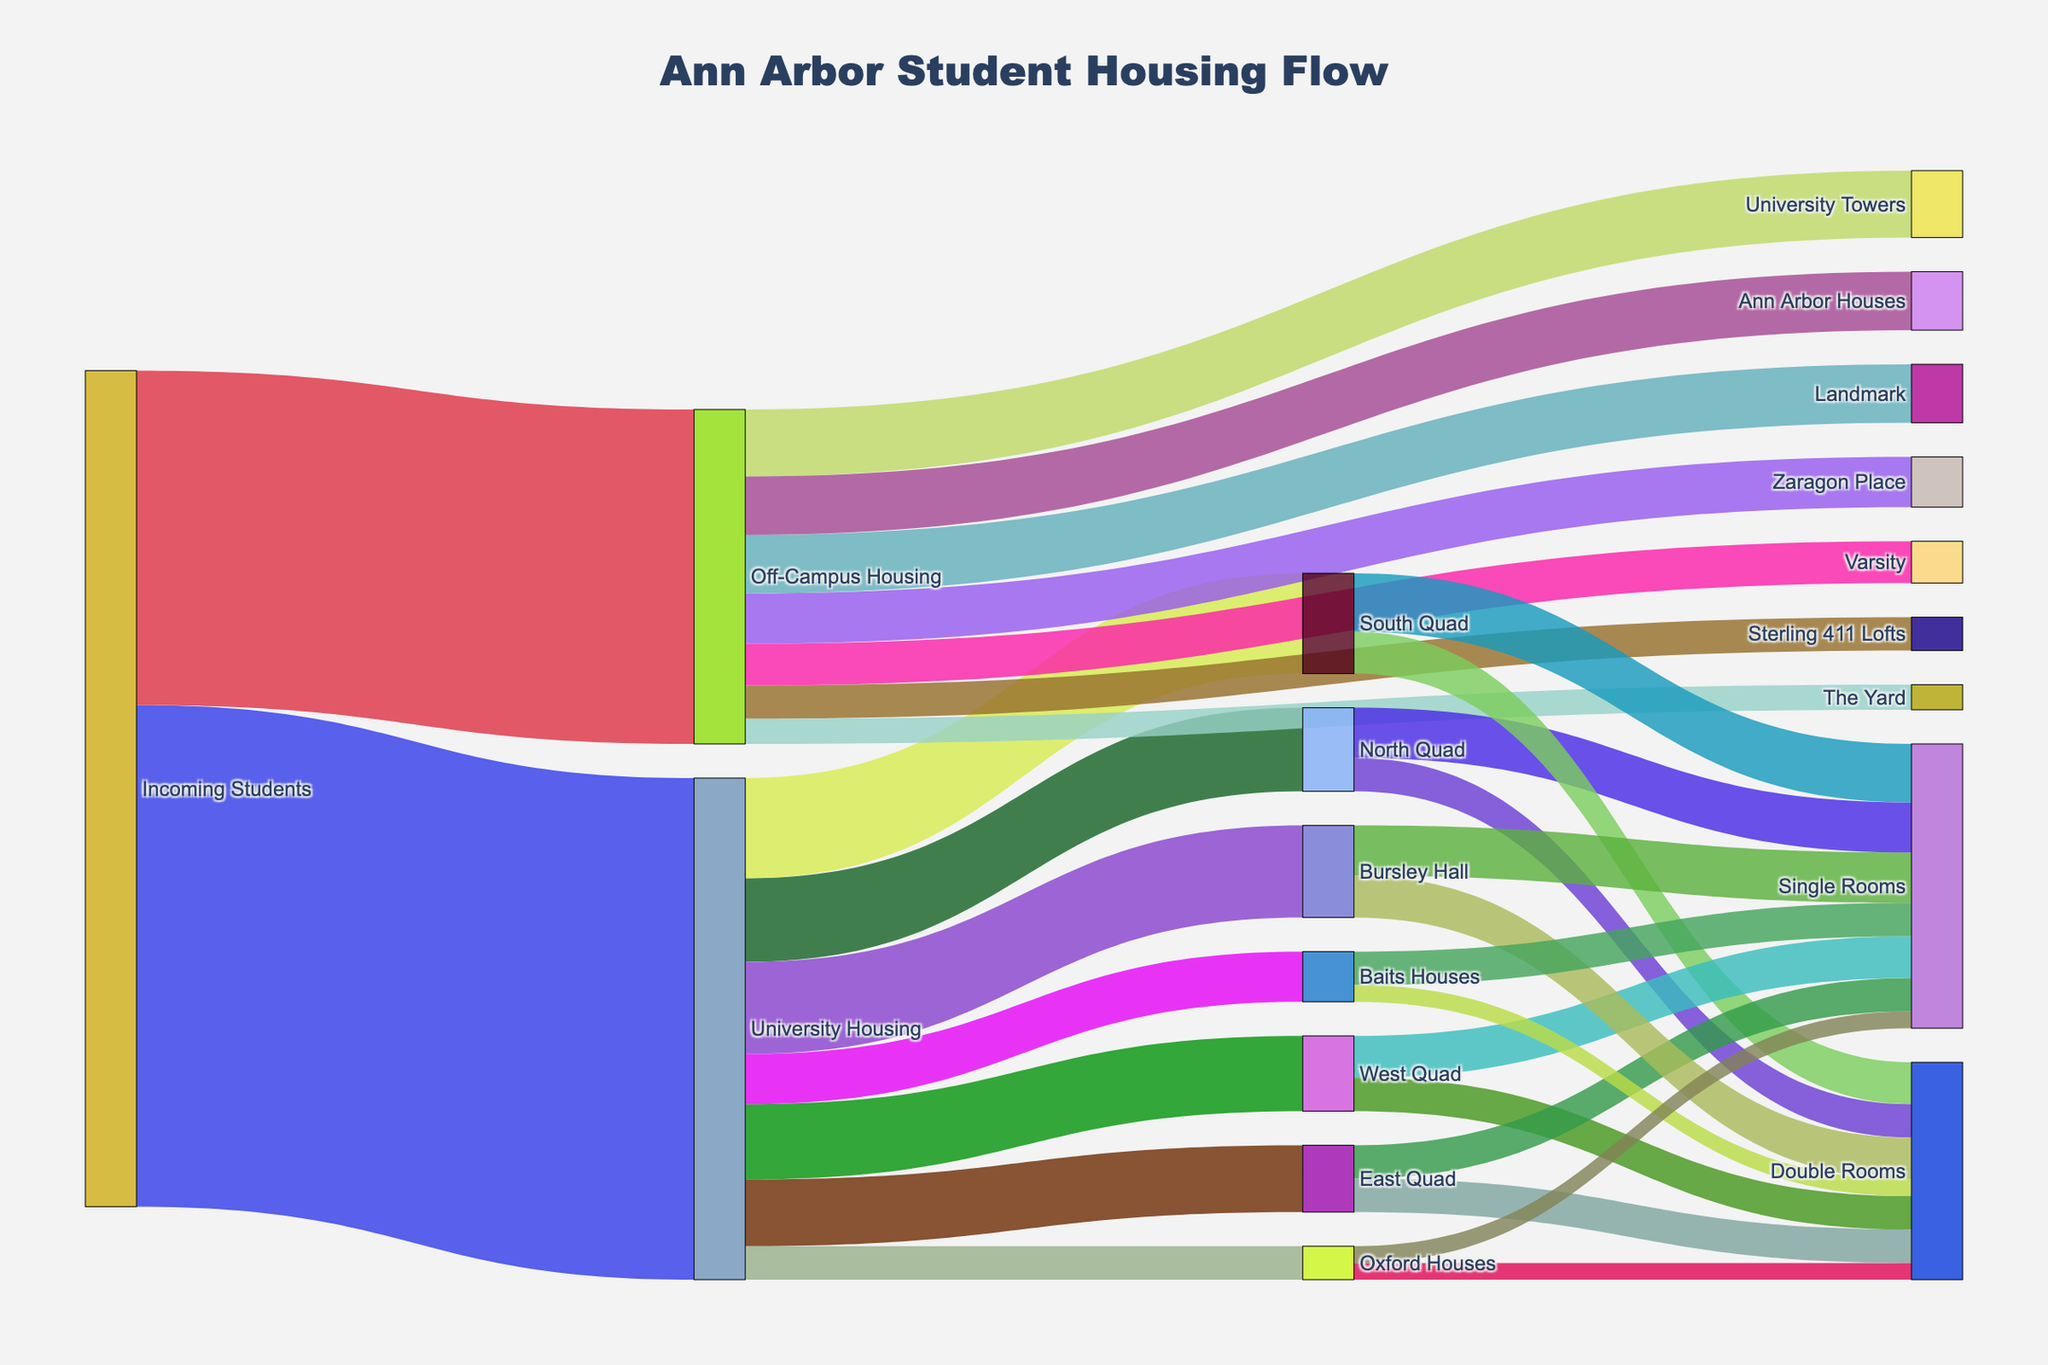how many students live in university housing? To find the total number of students living in university housing, sum all the values flowing from "University Housing" to specific dorms: 500 + 600 + 450 + 400 + 550 + 300 + 200 = 3000.
Answer: 3000 Which off-campus housing option accommodates the fewest students? To determine this, compare the values of all off-campus housing options. The Yard has the fewest students with a value of 150.
Answer: The Yard How many single rooms are available in total in University Housing? Summing up the values for all single room options in University Housing: 300 (North Quad) + 350 (South Quad) + 250 (West Quad) + 200 (East Quad) + 300 (Bursley Hall) + 200 (Baits Houses) + 100 (Oxford Houses) = 1700.
Answer: 1700 What's the difference between the number of students in University Housing and Off-Campus Housing? To find the difference, subtract the number of students in Off-Campus Housing (2000) from the number of students in University Housing (3000): 3000 - 2000 = 1000.
Answer: 1000 Which dorm has the highest number of students in double rooms? Compare the values of double rooms in each dorm. South Quad has the highest number with 250.
Answer: South Quad What is the total number of students in all types of North Quad rooms? Sum the values of single and double rooms in North Quad: 300 (Single Rooms) + 200 (Double Rooms) = 500.
Answer: 500 How do the accommodation numbers for Landmark and Varsity compare? Compare the values directly: Landmark has 350 students and Varsity has 250 students, so Landmark has 100 more students than Varsity.
Answer: Landmark Which dorm accommodates the same number of students in both single and double rooms? Identify dorms where single room and double room values are equal: Only East Quad and Oxford Houses have equal values, each with 200 and 100 respectively.
Answer: East Quad, Oxford Houses How many students are accommodated in Bursley Hall? Add the values for both single and double rooms in Bursley Hall: 300 (Single Rooms) + 250 (Double Rooms) = 550.
Answer: 550 What fraction of incoming students choose University Housing? The total number of incoming students is 5000 (3000 in University Housing, 2000 in Off-Campus Housing). The fraction for University Housing is 3000/5000 = 3/5.
Answer: 3/5 